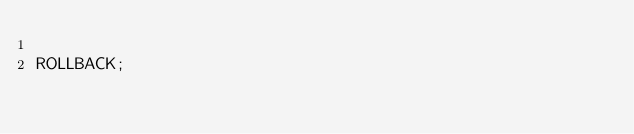Convert code to text. <code><loc_0><loc_0><loc_500><loc_500><_SQL_>
ROLLBACK;
</code> 